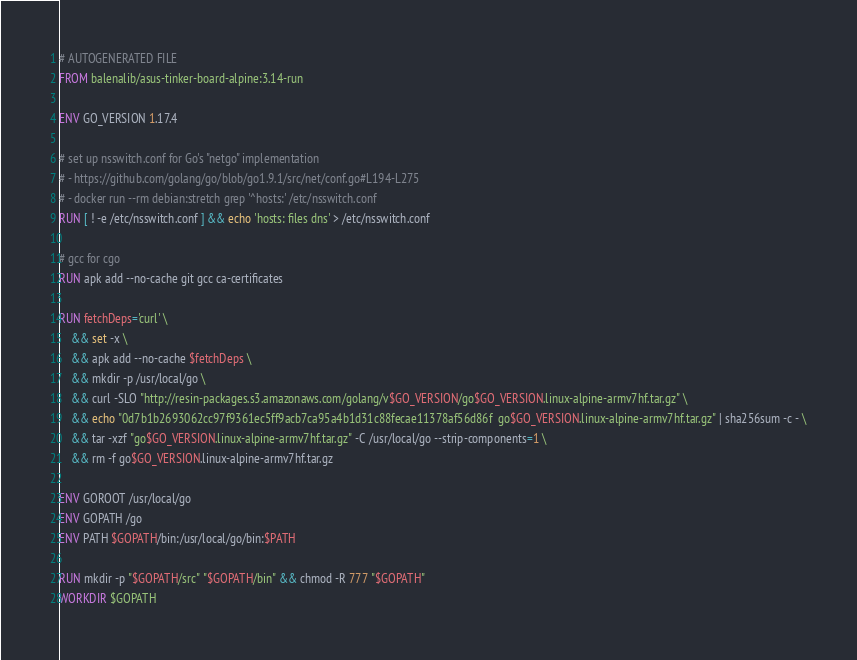Convert code to text. <code><loc_0><loc_0><loc_500><loc_500><_Dockerfile_># AUTOGENERATED FILE
FROM balenalib/asus-tinker-board-alpine:3.14-run

ENV GO_VERSION 1.17.4

# set up nsswitch.conf for Go's "netgo" implementation
# - https://github.com/golang/go/blob/go1.9.1/src/net/conf.go#L194-L275
# - docker run --rm debian:stretch grep '^hosts:' /etc/nsswitch.conf
RUN [ ! -e /etc/nsswitch.conf ] && echo 'hosts: files dns' > /etc/nsswitch.conf

# gcc for cgo
RUN apk add --no-cache git gcc ca-certificates

RUN fetchDeps='curl' \
	&& set -x \
	&& apk add --no-cache $fetchDeps \
	&& mkdir -p /usr/local/go \
	&& curl -SLO "http://resin-packages.s3.amazonaws.com/golang/v$GO_VERSION/go$GO_VERSION.linux-alpine-armv7hf.tar.gz" \
	&& echo "0d7b1b2693062cc97f9361ec5ff9acb7ca95a4b1d31c88fecae11378af56d86f  go$GO_VERSION.linux-alpine-armv7hf.tar.gz" | sha256sum -c - \
	&& tar -xzf "go$GO_VERSION.linux-alpine-armv7hf.tar.gz" -C /usr/local/go --strip-components=1 \
	&& rm -f go$GO_VERSION.linux-alpine-armv7hf.tar.gz

ENV GOROOT /usr/local/go
ENV GOPATH /go
ENV PATH $GOPATH/bin:/usr/local/go/bin:$PATH

RUN mkdir -p "$GOPATH/src" "$GOPATH/bin" && chmod -R 777 "$GOPATH"
WORKDIR $GOPATH
</code> 